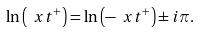Convert formula to latex. <formula><loc_0><loc_0><loc_500><loc_500>\ln \left ( \ x t ^ { + } \right ) = \ln \left ( - \ x t ^ { + } \right ) \pm i \pi .</formula> 